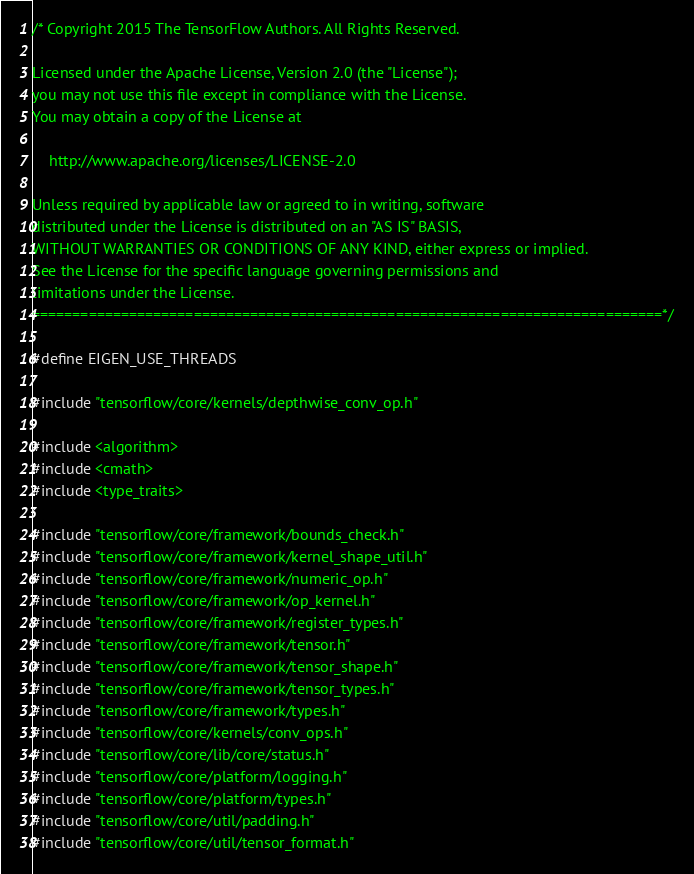Convert code to text. <code><loc_0><loc_0><loc_500><loc_500><_C++_>/* Copyright 2015 The TensorFlow Authors. All Rights Reserved.

Licensed under the Apache License, Version 2.0 (the "License");
you may not use this file except in compliance with the License.
You may obtain a copy of the License at

    http://www.apache.org/licenses/LICENSE-2.0

Unless required by applicable law or agreed to in writing, software
distributed under the License is distributed on an "AS IS" BASIS,
WITHOUT WARRANTIES OR CONDITIONS OF ANY KIND, either express or implied.
See the License for the specific language governing permissions and
limitations under the License.
==============================================================================*/

#define EIGEN_USE_THREADS

#include "tensorflow/core/kernels/depthwise_conv_op.h"

#include <algorithm>
#include <cmath>
#include <type_traits>

#include "tensorflow/core/framework/bounds_check.h"
#include "tensorflow/core/framework/kernel_shape_util.h"
#include "tensorflow/core/framework/numeric_op.h"
#include "tensorflow/core/framework/op_kernel.h"
#include "tensorflow/core/framework/register_types.h"
#include "tensorflow/core/framework/tensor.h"
#include "tensorflow/core/framework/tensor_shape.h"
#include "tensorflow/core/framework/tensor_types.h"
#include "tensorflow/core/framework/types.h"
#include "tensorflow/core/kernels/conv_ops.h"
#include "tensorflow/core/lib/core/status.h"
#include "tensorflow/core/platform/logging.h"
#include "tensorflow/core/platform/types.h"
#include "tensorflow/core/util/padding.h"
#include "tensorflow/core/util/tensor_format.h"</code> 